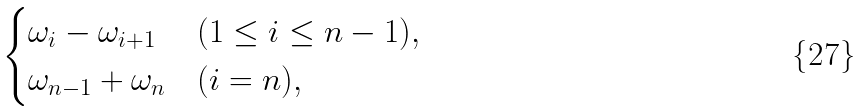Convert formula to latex. <formula><loc_0><loc_0><loc_500><loc_500>\begin{cases} \omega _ { i } - \omega _ { i + 1 } & ( 1 \leq i \leq n - 1 ) , \\ \omega _ { n - 1 } + \omega _ { n } & ( i = n ) , \end{cases}</formula> 